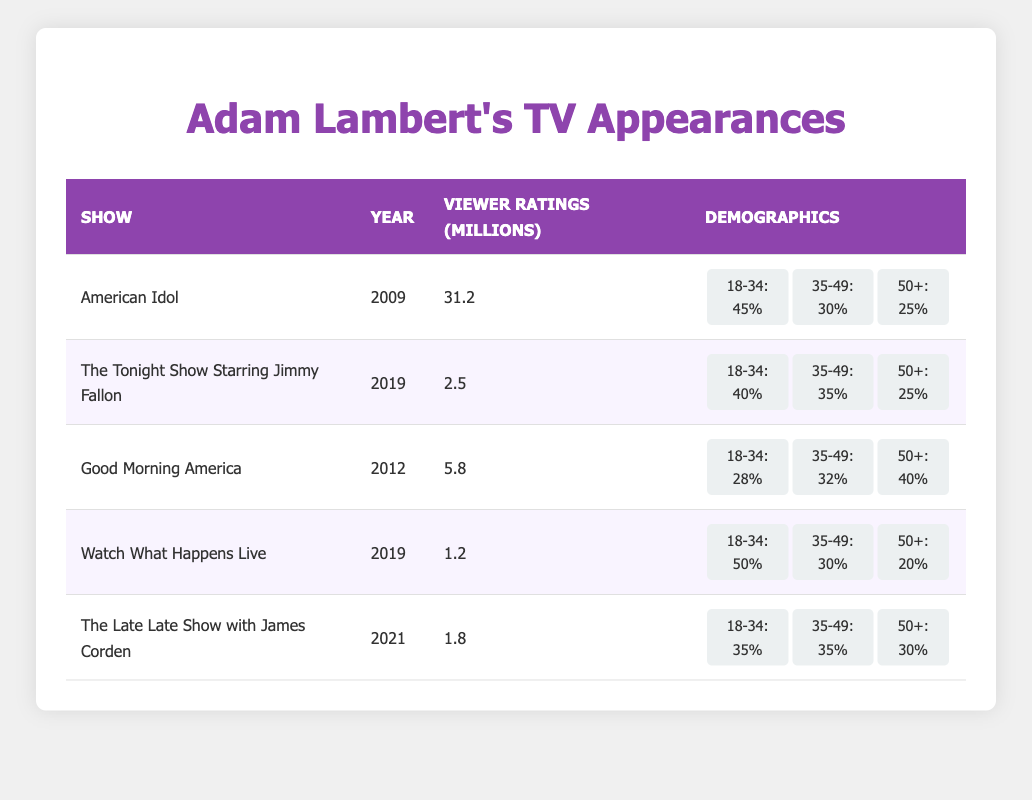What were the viewer ratings for Adam Lambert on "American Idol"? The table shows the viewer ratings for "American Idol" as 31.2 million.
Answer: 31.2 million Which show had the highest viewer ratings? "American Idol" had the highest viewer ratings at 31.2 million, as the table indicates.
Answer: "American Idol" What percentage of viewers aged 18-34 watched "Good Morning America"? The table indicates that 28% of viewers aged 18-34 watched "Good Morning America."
Answer: 28% True or False: The viewer ratings on "The Tonight Show Starring Jimmy Fallon" are higher than on "Watch What Happens Live." Comparing the two shows, "The Tonight Show Starring Jimmy Fallon" has 2.5 million while "Watch What Happens Live" has 1.2 million, making the statement true.
Answer: True What is the average viewer rating for Adam Lambert's appearances across all shows listed? To calculate the average, add all the viewer ratings: (31.2 + 2.5 + 5.8 + 1.2 + 1.8) = 42.5 million. Then divide by 5 (the number of shows): 42.5 million / 5 = 8.5 million.
Answer: 8.5 million Which age demographic saw the highest representation during Adam Lambert's appearance on "Watch What Happens Live"? According to the table, 50% of viewers aged 18-34 watched "Watch What Happens Live," which is the highest percentage for any age demographic for that show.
Answer: 18-34 How does the viewer demographic of "The Late Late Show with James Corden" differ between the 35-49 age group and the 50+ age group? The viewer demographic shows that both the 35-49 and 50+ age groups have 35% and 30% respectively; therefore, the 35-49 group is 5% higher.
Answer: 5% higher What is the total percentage of viewers aged 35-49 across all shows listed? Adding the percentages: 30 (American Idol) + 35 (The Tonight Show) + 32 (Good Morning America) + 30 (Watch What Happens Live) + 35 (Late Late Show) = 162%. The total percentage is 162%.
Answer: 162% In which year did Adam Lambert have his appearance with the lowest viewer ratings? The lowest viewer ratings were for "Watch What Happens Live" in 2019 with 1.2 million viewers, as shown in the table.
Answer: 2019 